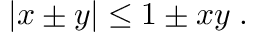<formula> <loc_0><loc_0><loc_500><loc_500>\begin{array} { r } { | x \pm y | \leq 1 \pm x y \, . } \end{array}</formula> 